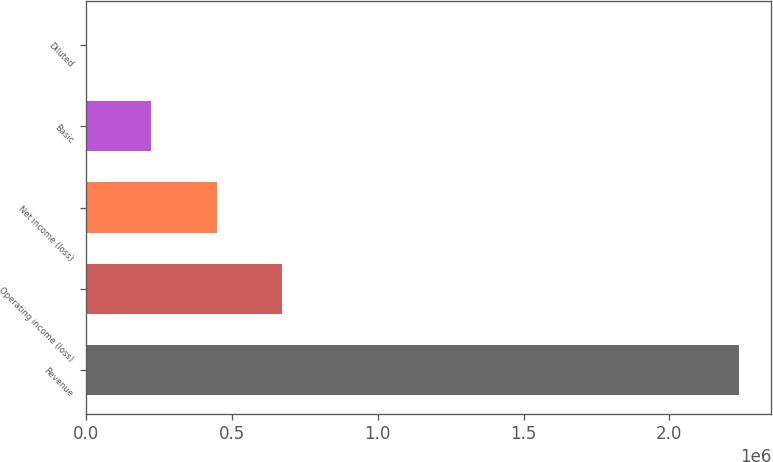<chart> <loc_0><loc_0><loc_500><loc_500><bar_chart><fcel>Revenue<fcel>Operating income (loss)<fcel>Net income (loss)<fcel>Basic<fcel>Diluted<nl><fcel>2.23759e+06<fcel>671276<fcel>447518<fcel>223759<fcel>0.7<nl></chart> 